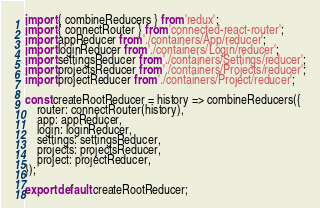Convert code to text. <code><loc_0><loc_0><loc_500><loc_500><_JavaScript_>import { combineReducers } from 'redux';
import { connectRouter } from 'connected-react-router';
import appReducer from './containers/App/reducer';
import loginReducer from './containers/Login/reducer';
import settingsReducer from './containers/Settings/reducer';
import projectsReducer from './containers/Projects/reducer';
import projectReducer from './containers/Project/reducer';

const createRootReducer = history => combineReducers({
    router: connectRouter(history),
    app: appReducer,
    login: loginReducer,
    settings: settingsReducer,
    projects: projectsReducer,
    project: projectReducer,
});

export default createRootReducer;
</code> 